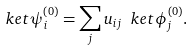Convert formula to latex. <formula><loc_0><loc_0><loc_500><loc_500>\ k e t { \psi _ { i } ^ { \left ( 0 \right ) } } = \sum _ { j } u _ { i j } \ k e t { \phi _ { j } ^ { \left ( 0 \right ) } } .</formula> 